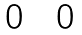Convert formula to latex. <formula><loc_0><loc_0><loc_500><loc_500>\begin{matrix} 0 & & 0 \end{matrix}</formula> 